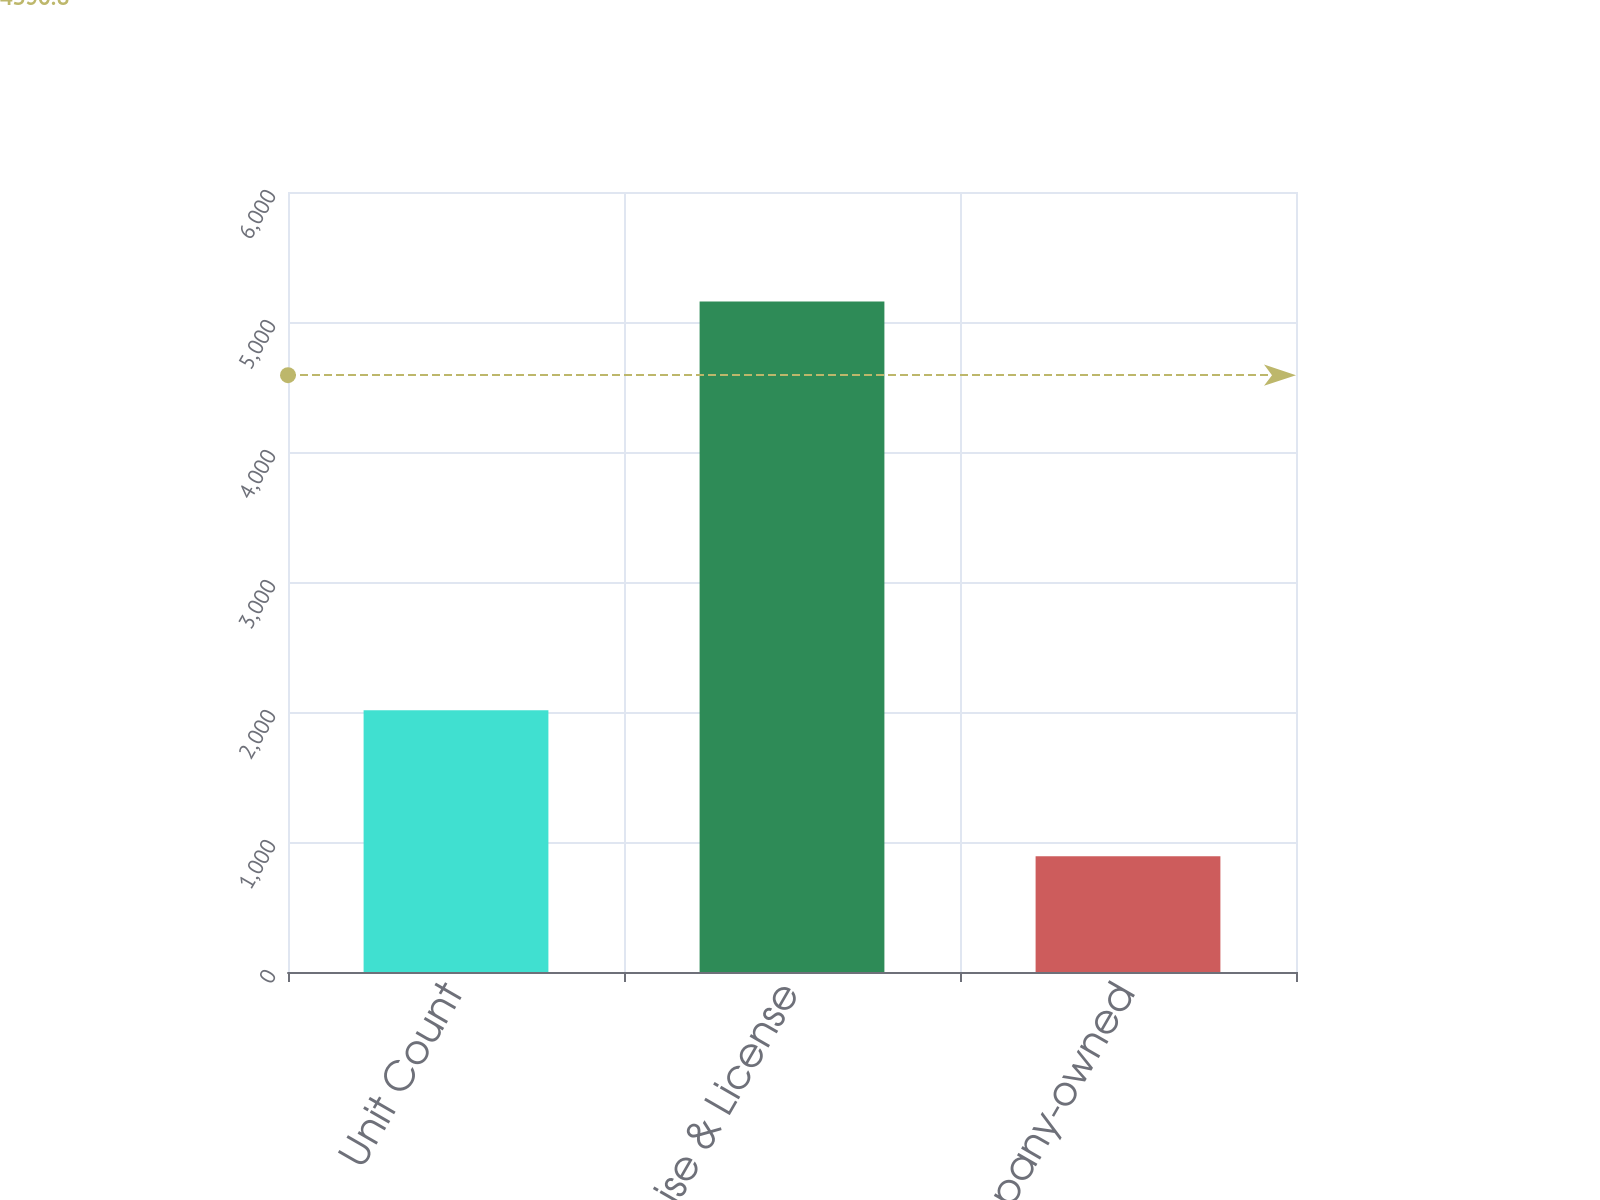Convert chart to OTSL. <chart><loc_0><loc_0><loc_500><loc_500><bar_chart><fcel>Unit Count<fcel>Franchise & License<fcel>Company-owned<nl><fcel>2013<fcel>5157<fcel>891<nl></chart> 